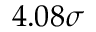Convert formula to latex. <formula><loc_0><loc_0><loc_500><loc_500>4 . 0 8 \sigma</formula> 